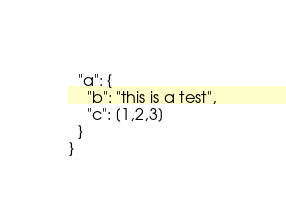Convert code to text. <code><loc_0><loc_0><loc_500><loc_500><_JavaScript_>  "a": {
    "b": "this is a test",
    "c": [1,2,3]
  }
}
</code> 